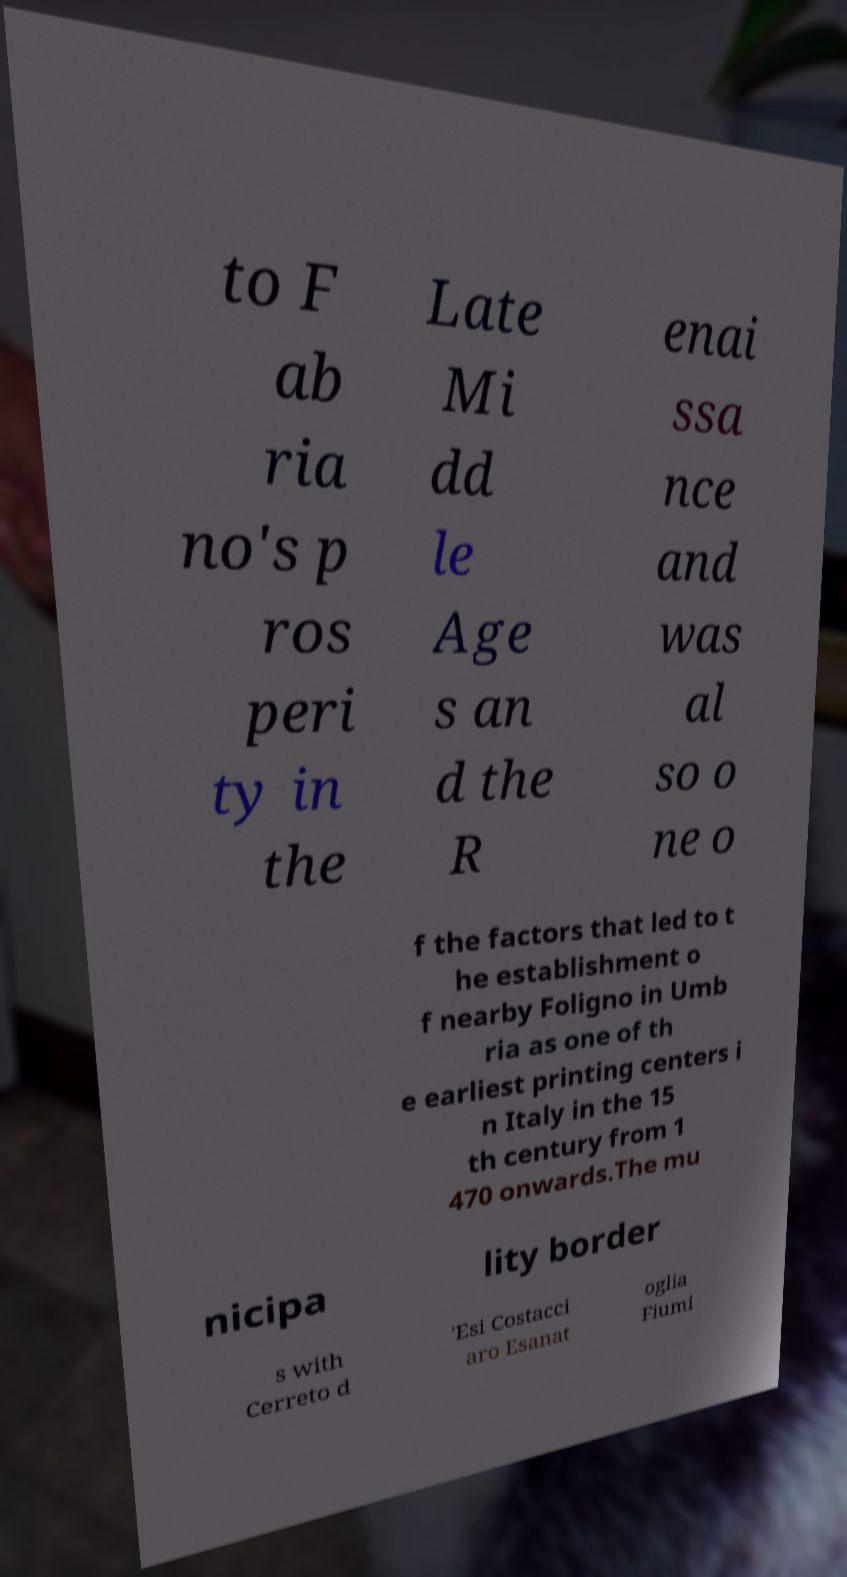Please identify and transcribe the text found in this image. to F ab ria no's p ros peri ty in the Late Mi dd le Age s an d the R enai ssa nce and was al so o ne o f the factors that led to t he establishment o f nearby Foligno in Umb ria as one of th e earliest printing centers i n Italy in the 15 th century from 1 470 onwards.The mu nicipa lity border s with Cerreto d 'Esi Costacci aro Esanat oglia Fiumi 